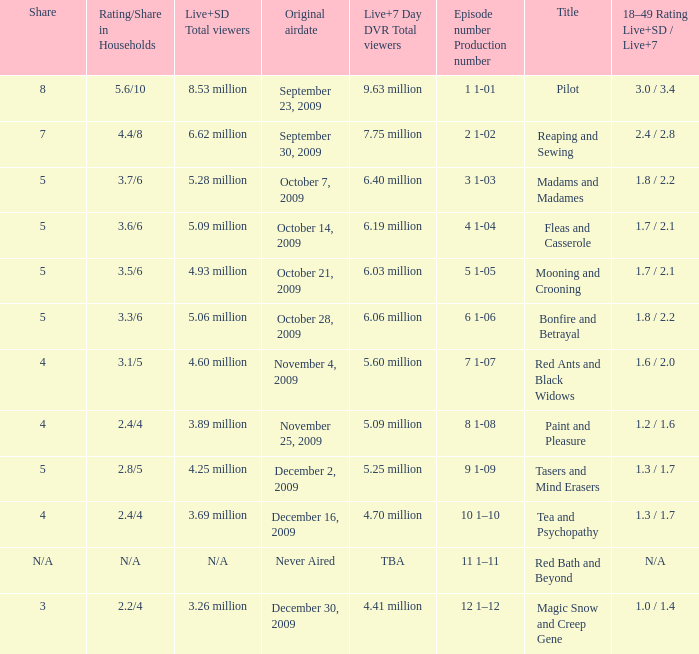How many total viewers (combined Live and SD) watched the episode with a share of 8? 9.63 million. 